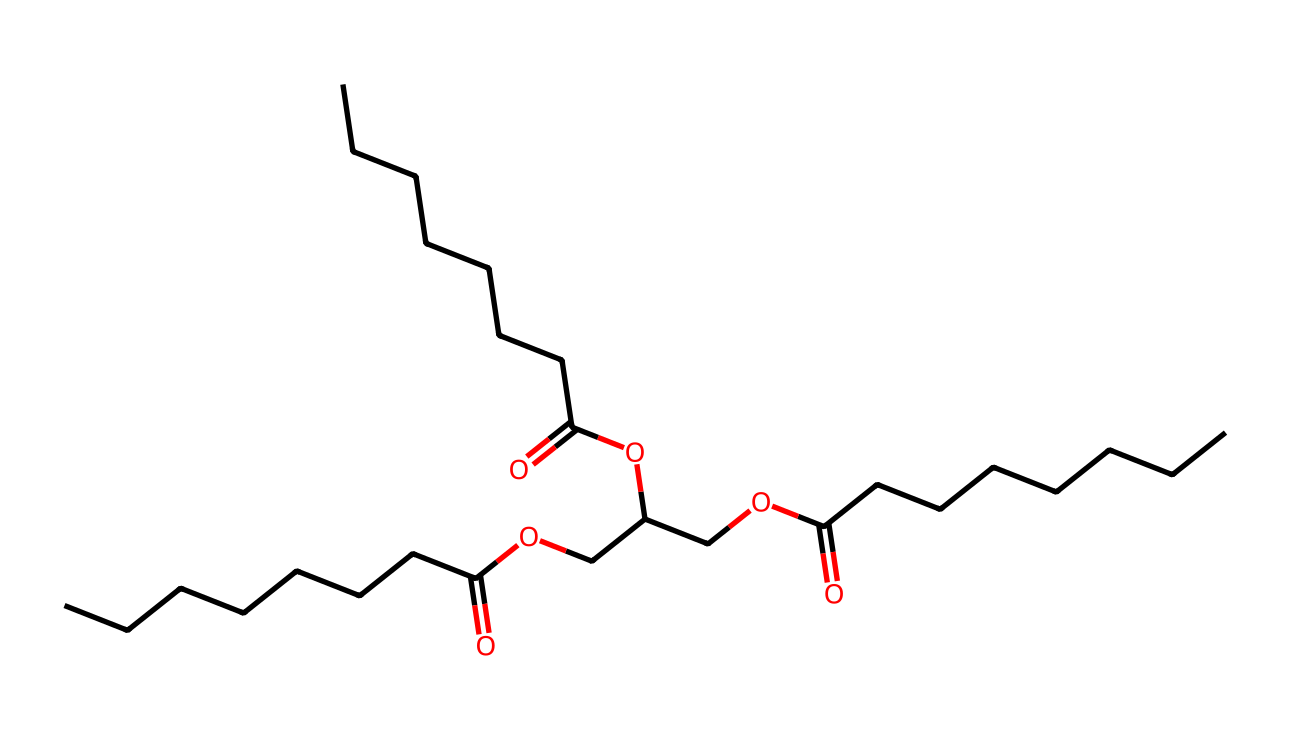What is the total number of carbon atoms in the molecule? The SMILES representation indicates multiple hydrocarbon chains. Counting each 'C' in the representation reveals a total of 27 carbon atoms present in the structure.
Answer: 27 How many ester functional groups are present in this molecule? The ester functional groups can be identified by the 'C(=O)O' structure appearing multiple times in the SMILES notation. In this representation, there are three instances of this structure, indicating three ester functional groups.
Answer: 3 What is the main functional group in this biodegradable lubricant? In the structure, the recurring 'C(=O)O' indicates the presence of carboxylic acids or ester functional groups, which are characteristic of biodegradable lubricants. This signifies that the main functional group is an ester.
Answer: ester What is the longest hydrocarbon chain in the molecule? By examining the SMILES representation, the longest continuous chain of carbon atoms without disruption is found to be linear, constituting 9 carbon atoms (CCCCCCCCC segment). Therefore, the longest hydrocarbon chain in the molecule consists of 9 carbon atoms.
Answer: 9 Does this molecule likely have a high or low viscosity? The presence of long hydrocarbon chains typically indicates that the substance has a higher viscosity due to increased intermolecular interactions such as Van der Waals forces between the chains. Therefore, this molecule would likely have a high viscosity.
Answer: high How many unique components can you identify from the molecular structure? By analyzing the structure and identifying the groups present (e.g., the various alkyl groups and ester functionalities), we can see that there are at least three distinct repeating components. This indicates that the molecule has several unique components.
Answer: 3 